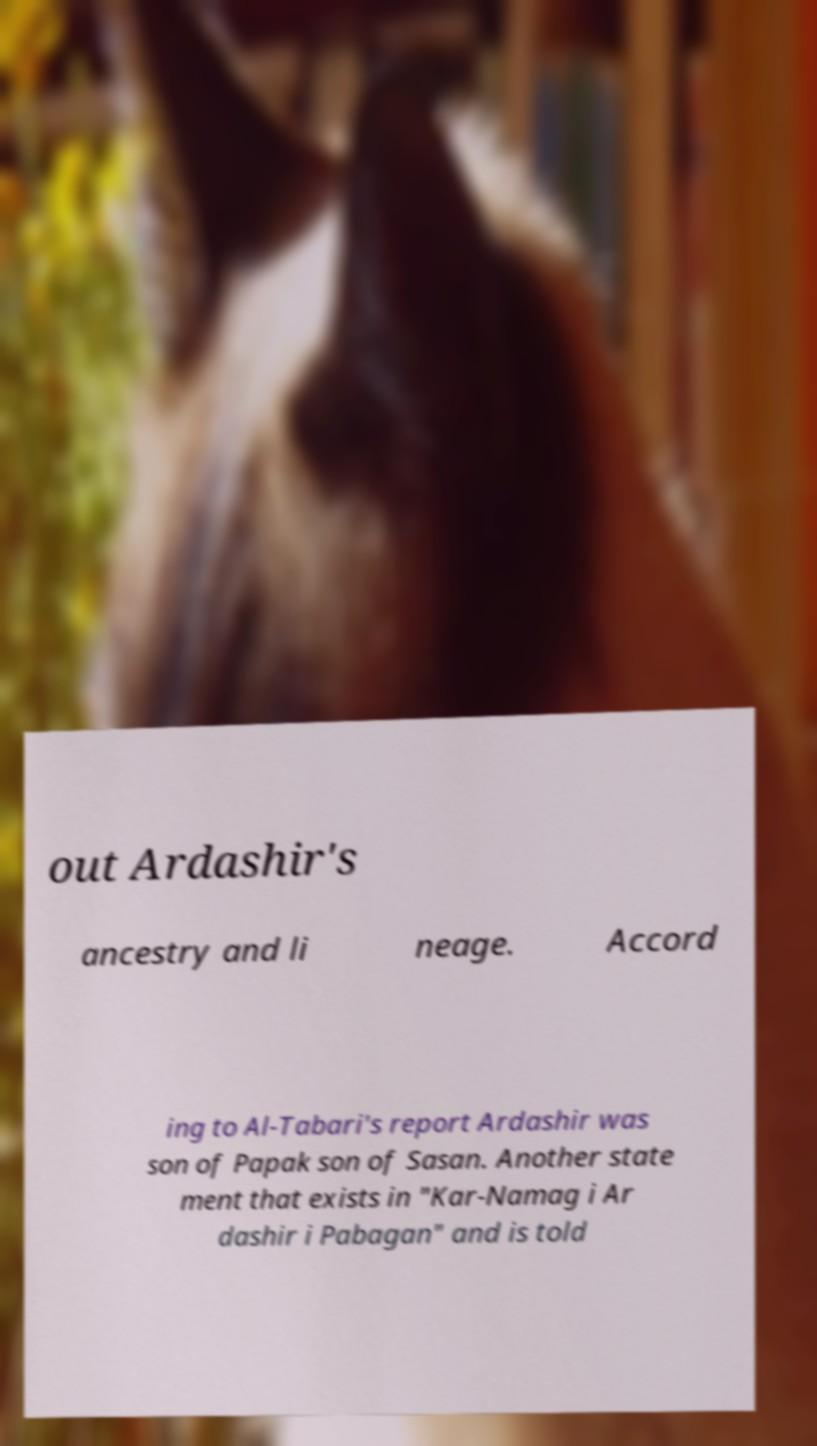For documentation purposes, I need the text within this image transcribed. Could you provide that? out Ardashir's ancestry and li neage. Accord ing to Al-Tabari's report Ardashir was son of Papak son of Sasan. Another state ment that exists in "Kar-Namag i Ar dashir i Pabagan" and is told 